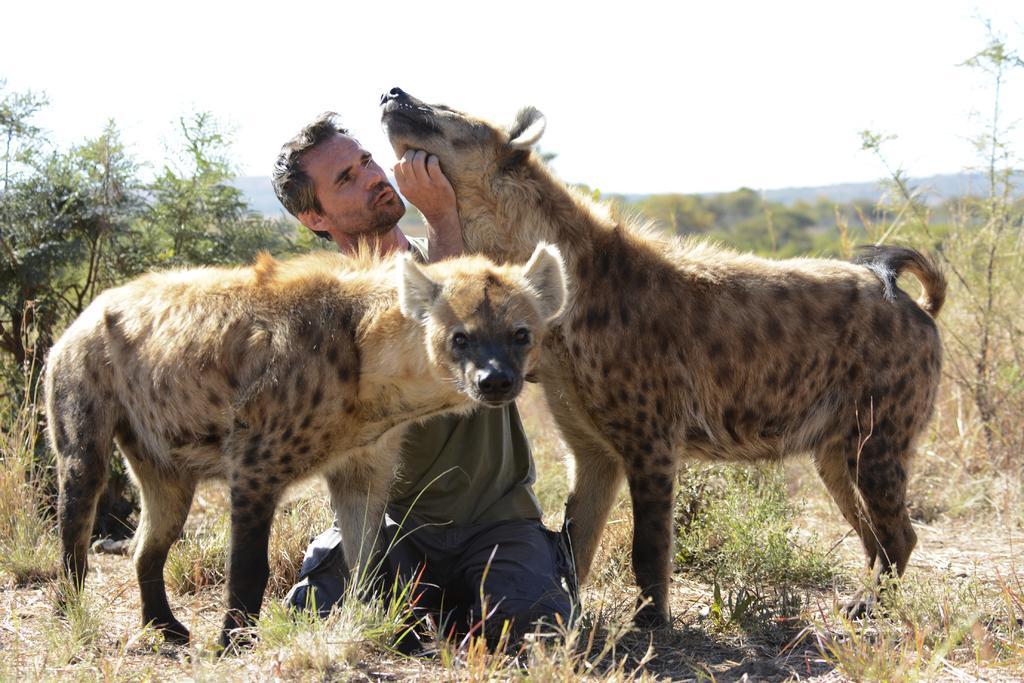Please provide a concise description of this image. This picture shows couple of hyenas and we see a man seated and touching it with this hand and we see trees, Plants and grass on the ground. 